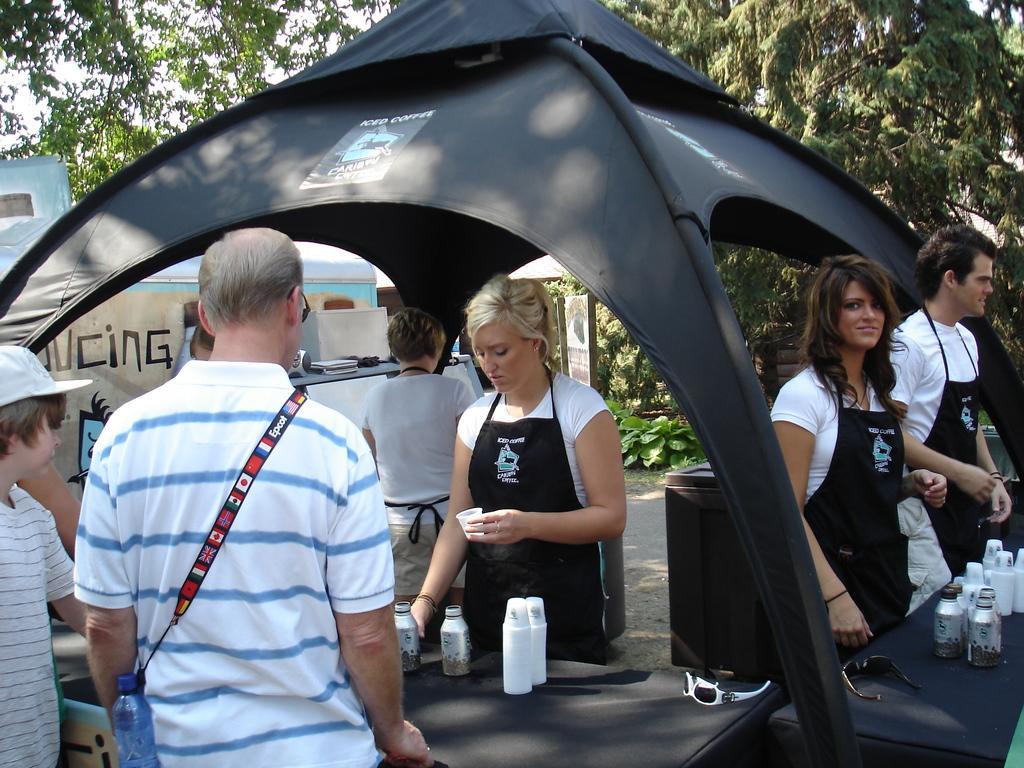In one or two sentences, can you explain what this image depicts? To the left corner of the image there is a boy with white t-shirt and a cap on his head is standing. Beside him there is a man with white t-shirt and blue lines with bottle is standing. In front of him there is a table with bottles and glasses. Behind the table there is a lady with black apron and white t-shirt. And to the right side of the image there are two people with white t-shirt and black apron is standing and in front of them there is a table with glasses, bottles and goggles. They are standing under the black tent. In the background there are trees. 